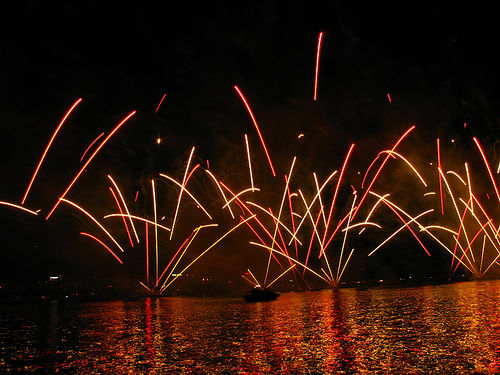<image>
Can you confirm if the smoke is next to the water? Yes. The smoke is positioned adjacent to the water, located nearby in the same general area. 